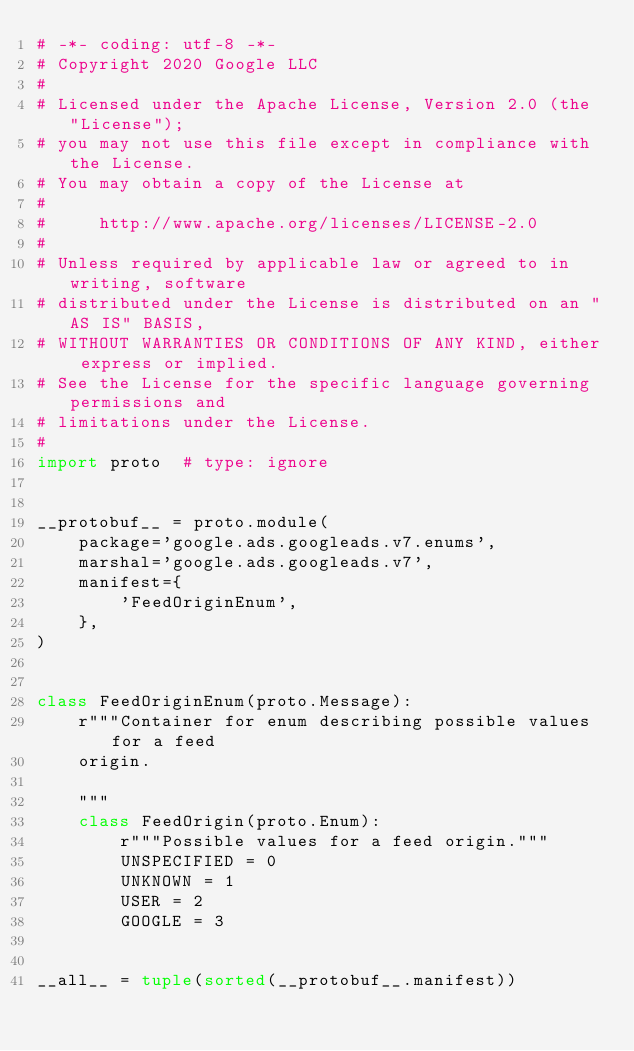<code> <loc_0><loc_0><loc_500><loc_500><_Python_># -*- coding: utf-8 -*-
# Copyright 2020 Google LLC
#
# Licensed under the Apache License, Version 2.0 (the "License");
# you may not use this file except in compliance with the License.
# You may obtain a copy of the License at
#
#     http://www.apache.org/licenses/LICENSE-2.0
#
# Unless required by applicable law or agreed to in writing, software
# distributed under the License is distributed on an "AS IS" BASIS,
# WITHOUT WARRANTIES OR CONDITIONS OF ANY KIND, either express or implied.
# See the License for the specific language governing permissions and
# limitations under the License.
#
import proto  # type: ignore


__protobuf__ = proto.module(
    package='google.ads.googleads.v7.enums',
    marshal='google.ads.googleads.v7',
    manifest={
        'FeedOriginEnum',
    },
)


class FeedOriginEnum(proto.Message):
    r"""Container for enum describing possible values for a feed
    origin.

    """
    class FeedOrigin(proto.Enum):
        r"""Possible values for a feed origin."""
        UNSPECIFIED = 0
        UNKNOWN = 1
        USER = 2
        GOOGLE = 3


__all__ = tuple(sorted(__protobuf__.manifest))
</code> 